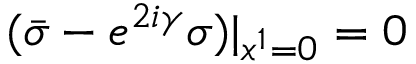Convert formula to latex. <formula><loc_0><loc_0><loc_500><loc_500>( { \bar { \sigma } } - e ^ { 2 i \gamma } \sigma ) | _ { x ^ { 1 } = 0 } = 0</formula> 